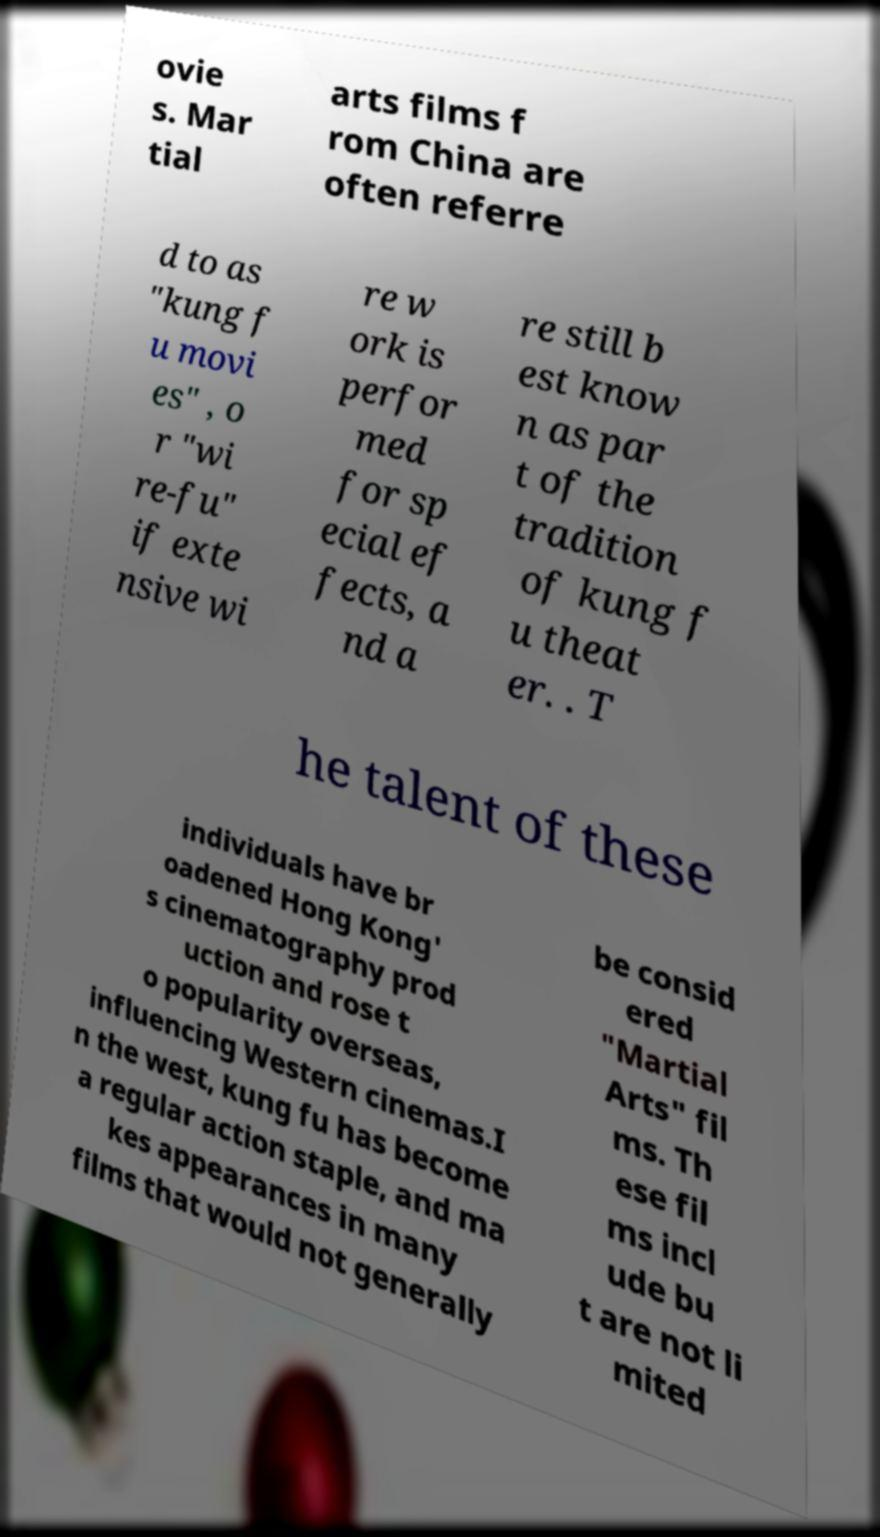Could you extract and type out the text from this image? ovie s. Mar tial arts films f rom China are often referre d to as "kung f u movi es" , o r "wi re-fu" if exte nsive wi re w ork is perfor med for sp ecial ef fects, a nd a re still b est know n as par t of the tradition of kung f u theat er. . T he talent of these individuals have br oadened Hong Kong' s cinematography prod uction and rose t o popularity overseas, influencing Western cinemas.I n the west, kung fu has become a regular action staple, and ma kes appearances in many films that would not generally be consid ered "Martial Arts" fil ms. Th ese fil ms incl ude bu t are not li mited 